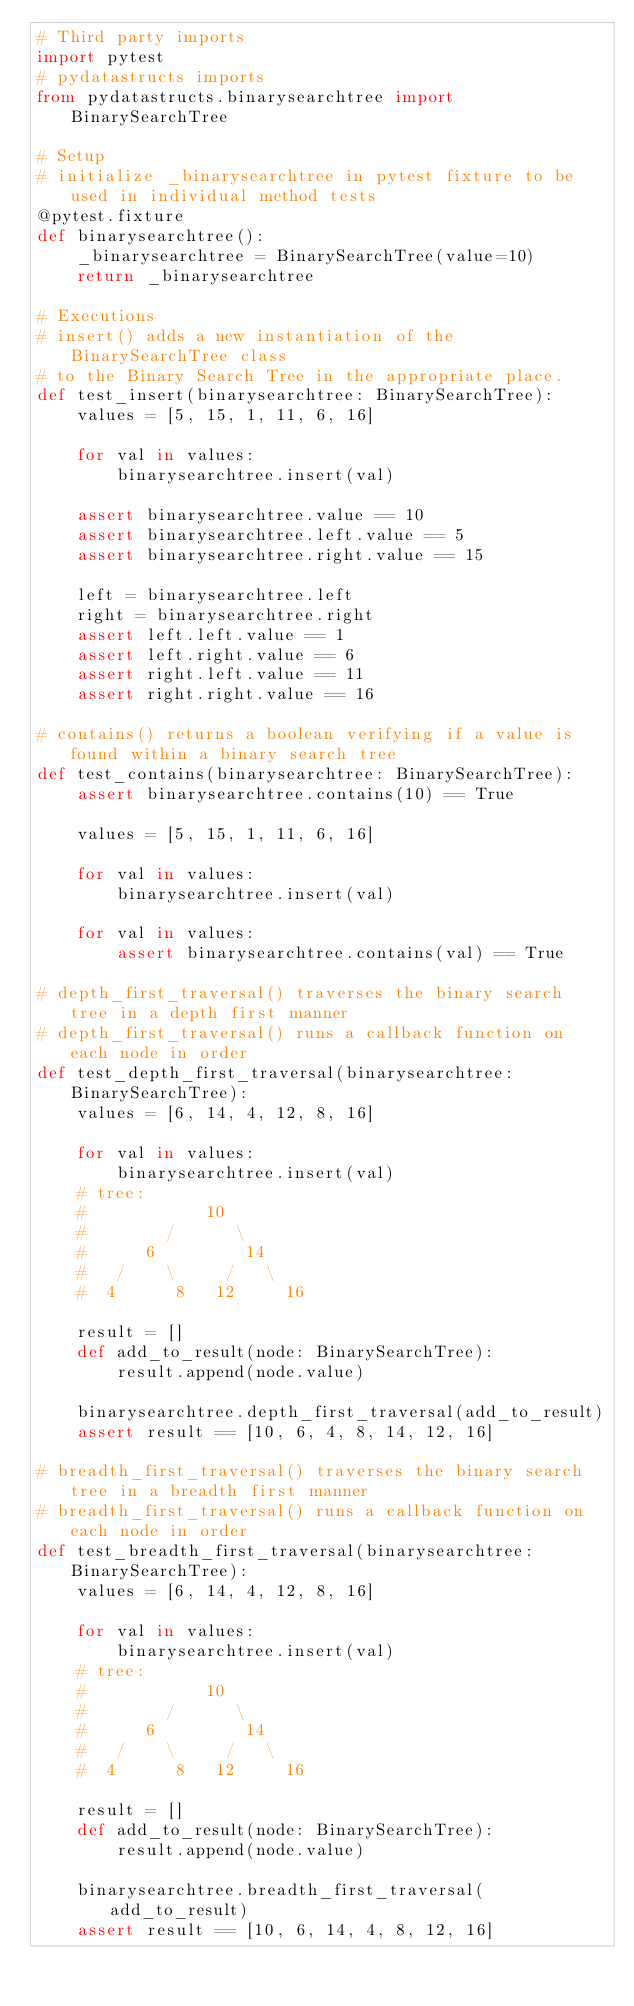Convert code to text. <code><loc_0><loc_0><loc_500><loc_500><_Python_># Third party imports
import pytest
# pydatastructs imports
from pydatastructs.binarysearchtree import BinarySearchTree

# Setup
# initialize _binarysearchtree in pytest fixture to be used in individual method tests
@pytest.fixture
def binarysearchtree():
    _binarysearchtree = BinarySearchTree(value=10)
    return _binarysearchtree

# Executions
# insert() adds a new instantiation of the BinarySearchTree class
# to the Binary Search Tree in the appropriate place.
def test_insert(binarysearchtree: BinarySearchTree):
    values = [5, 15, 1, 11, 6, 16]

    for val in values:
        binarysearchtree.insert(val)
    
    assert binarysearchtree.value == 10
    assert binarysearchtree.left.value == 5
    assert binarysearchtree.right.value == 15

    left = binarysearchtree.left
    right = binarysearchtree.right
    assert left.left.value == 1
    assert left.right.value == 6
    assert right.left.value == 11
    assert right.right.value == 16

# contains() returns a boolean verifying if a value is found within a binary search tree
def test_contains(binarysearchtree: BinarySearchTree):
    assert binarysearchtree.contains(10) == True

    values = [5, 15, 1, 11, 6, 16]

    for val in values:
        binarysearchtree.insert(val)
    
    for val in values:
        assert binarysearchtree.contains(val) == True

# depth_first_traversal() traverses the binary search tree in a depth first manner
# depth_first_traversal() runs a callback function on each node in order
def test_depth_first_traversal(binarysearchtree: BinarySearchTree):
    values = [6, 14, 4, 12, 8, 16]

    for val in values:
        binarysearchtree.insert(val)
    # tree: 
    #            10
    #        /      \
    #      6         14
    #   /    \     /   \
    #  4      8   12     16

    result = []
    def add_to_result(node: BinarySearchTree):
        result.append(node.value)
    
    binarysearchtree.depth_first_traversal(add_to_result)
    assert result == [10, 6, 4, 8, 14, 12, 16]

# breadth_first_traversal() traverses the binary search tree in a breadth first manner
# breadth_first_traversal() runs a callback function on each node in order
def test_breadth_first_traversal(binarysearchtree: BinarySearchTree):
    values = [6, 14, 4, 12, 8, 16]

    for val in values:
        binarysearchtree.insert(val)
    # tree: 
    #            10
    #        /      \
    #      6         14
    #   /    \     /   \
    #  4      8   12     16

    result = []
    def add_to_result(node: BinarySearchTree):
        result.append(node.value)
    
    binarysearchtree.breadth_first_traversal(add_to_result)
    assert result == [10, 6, 14, 4, 8, 12, 16]</code> 